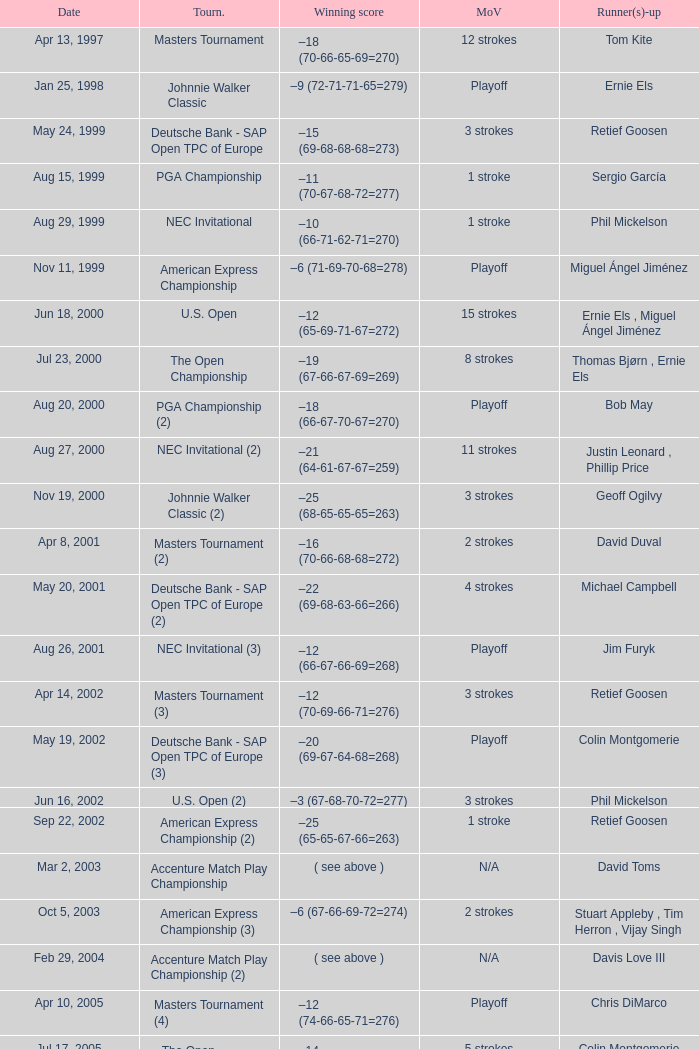Who has the Winning score of –10 (66-71-62-71=270) ? Phil Mickelson. 